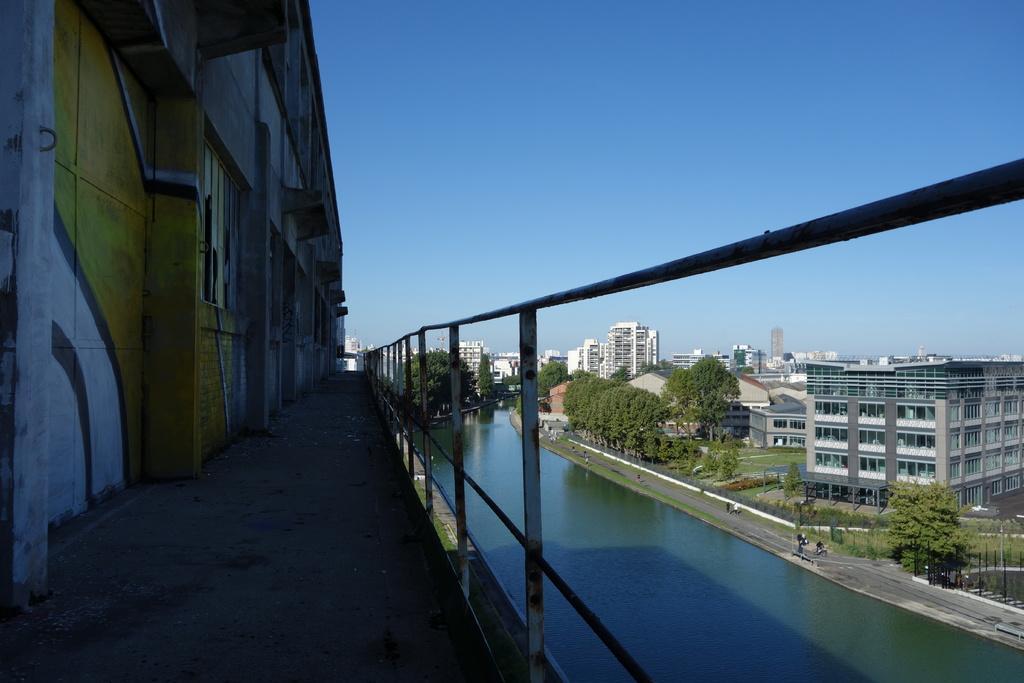In one or two sentences, can you explain what this image depicts? In the picture I can see the wall on the left side of the image, here I can see the steel railing, I can see water, trees, grass, I can see the buildings and the blue color sky in the background. 